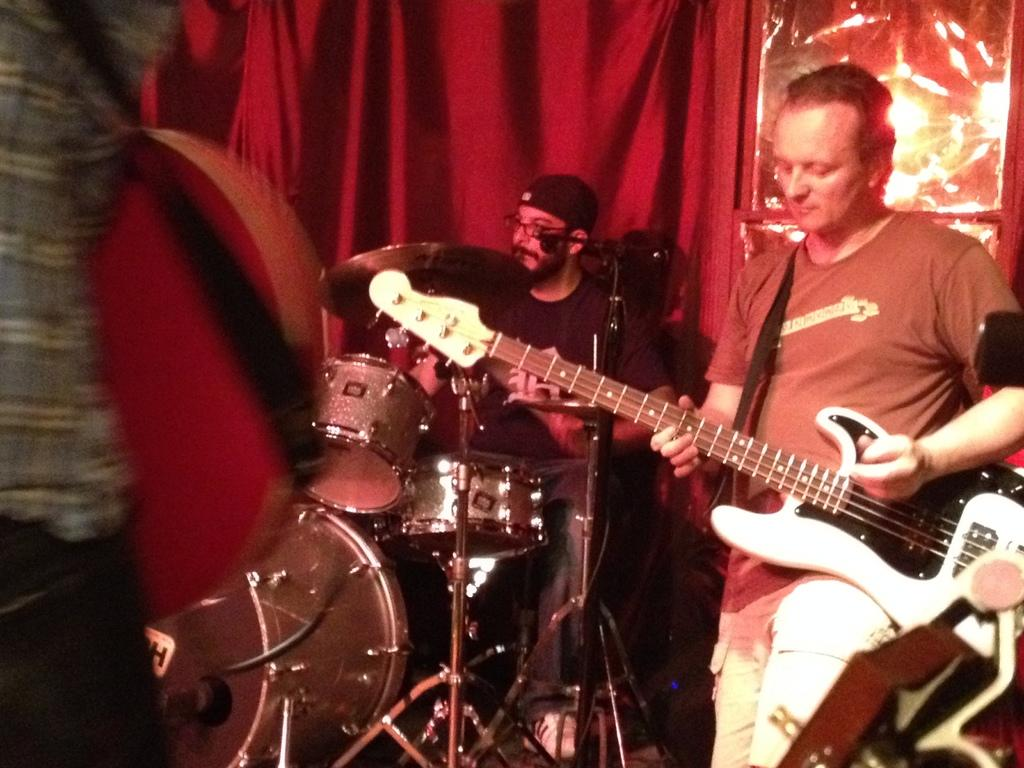What are the people in the image doing? The people in the image are playing musical instruments. Can you describe the appearance of the middle person? The middle person is wearing glasses and a cap on his head. What can be seen in the background of the image? There is a red color curtain in the background of the image. How many tickets are visible on the floor in the image? There are no tickets visible on the floor in the image. Can you describe the icicles hanging from the ceiling in the image? There are no icicles present in the image. 